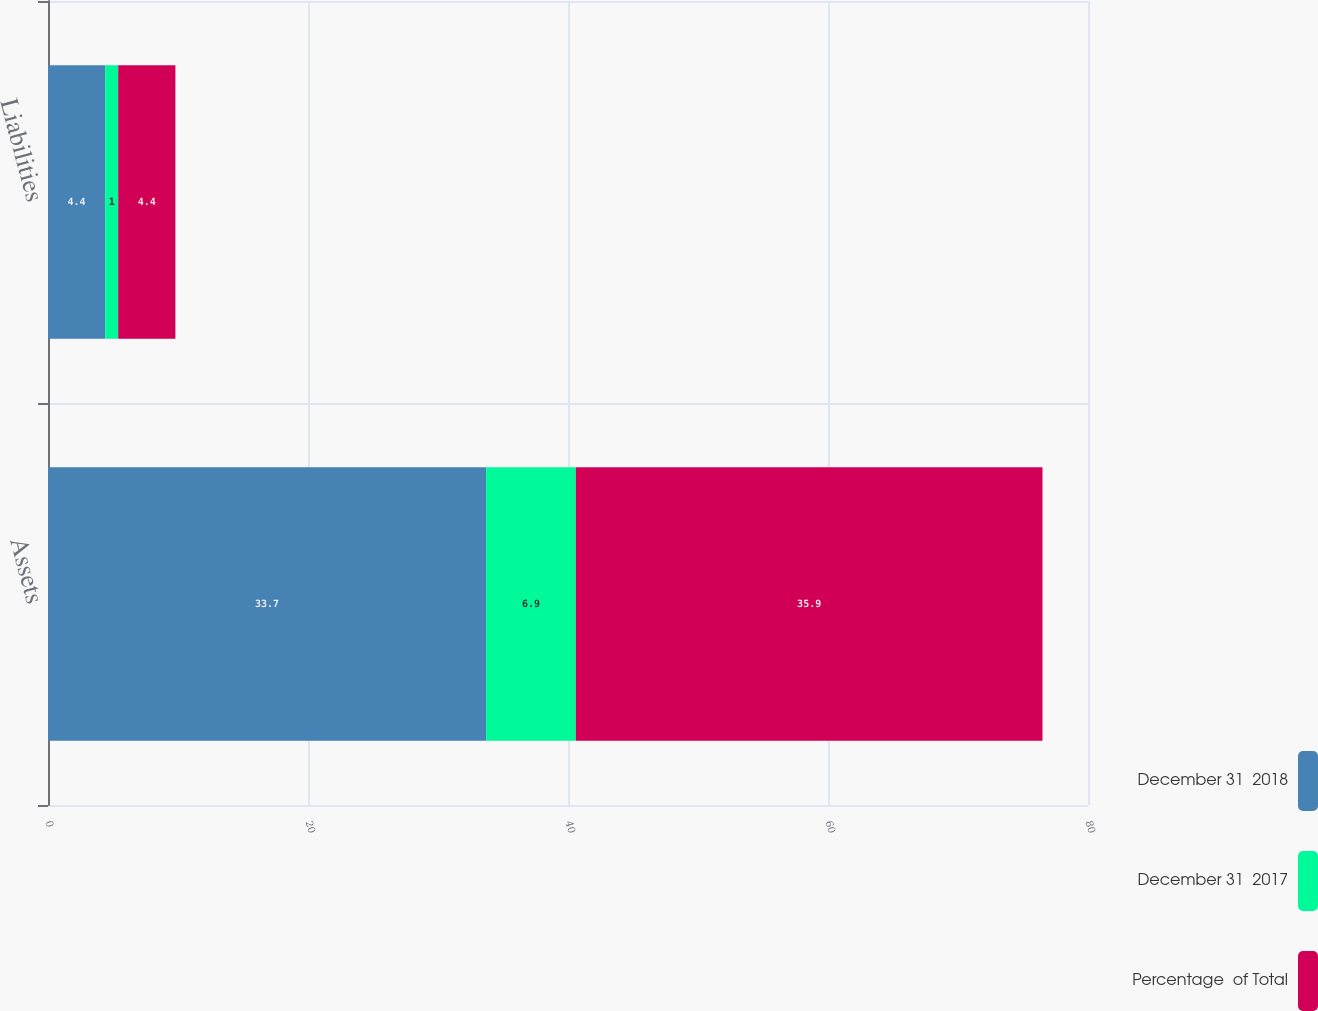Convert chart to OTSL. <chart><loc_0><loc_0><loc_500><loc_500><stacked_bar_chart><ecel><fcel>Assets<fcel>Liabilities<nl><fcel>December 31  2018<fcel>33.7<fcel>4.4<nl><fcel>December 31  2017<fcel>6.9<fcel>1<nl><fcel>Percentage  of Total<fcel>35.9<fcel>4.4<nl></chart> 